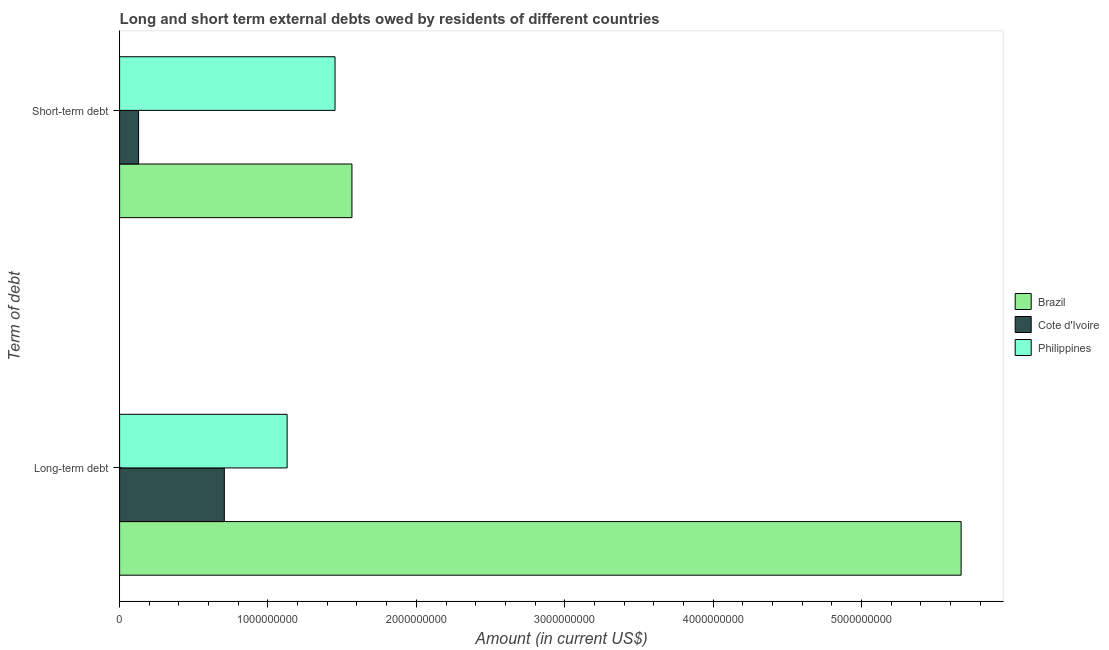How many groups of bars are there?
Provide a short and direct response. 2. Are the number of bars on each tick of the Y-axis equal?
Offer a terse response. Yes. What is the label of the 2nd group of bars from the top?
Provide a short and direct response. Long-term debt. What is the long-term debts owed by residents in Cote d'Ivoire?
Your answer should be compact. 7.06e+08. Across all countries, what is the maximum short-term debts owed by residents?
Provide a succinct answer. 1.57e+09. Across all countries, what is the minimum long-term debts owed by residents?
Ensure brevity in your answer.  7.06e+08. In which country was the long-term debts owed by residents maximum?
Give a very brief answer. Brazil. In which country was the short-term debts owed by residents minimum?
Provide a short and direct response. Cote d'Ivoire. What is the total short-term debts owed by residents in the graph?
Provide a short and direct response. 3.15e+09. What is the difference between the short-term debts owed by residents in Philippines and that in Brazil?
Keep it short and to the point. -1.14e+08. What is the difference between the long-term debts owed by residents in Brazil and the short-term debts owed by residents in Cote d'Ivoire?
Offer a terse response. 5.54e+09. What is the average long-term debts owed by residents per country?
Offer a very short reply. 2.50e+09. What is the difference between the long-term debts owed by residents and short-term debts owed by residents in Brazil?
Keep it short and to the point. 4.11e+09. In how many countries, is the long-term debts owed by residents greater than 3600000000 US$?
Offer a terse response. 1. What is the ratio of the short-term debts owed by residents in Philippines to that in Brazil?
Provide a succinct answer. 0.93. Is the short-term debts owed by residents in Brazil less than that in Philippines?
Make the answer very short. No. In how many countries, is the long-term debts owed by residents greater than the average long-term debts owed by residents taken over all countries?
Provide a succinct answer. 1. What does the 1st bar from the bottom in Long-term debt represents?
Offer a terse response. Brazil. How many bars are there?
Give a very brief answer. 6. What is the difference between two consecutive major ticks on the X-axis?
Keep it short and to the point. 1.00e+09. Are the values on the major ticks of X-axis written in scientific E-notation?
Offer a terse response. No. Does the graph contain any zero values?
Provide a succinct answer. No. Does the graph contain grids?
Make the answer very short. No. How are the legend labels stacked?
Make the answer very short. Vertical. What is the title of the graph?
Your response must be concise. Long and short term external debts owed by residents of different countries. What is the label or title of the Y-axis?
Provide a succinct answer. Term of debt. What is the Amount (in current US$) of Brazil in Long-term debt?
Your response must be concise. 5.67e+09. What is the Amount (in current US$) of Cote d'Ivoire in Long-term debt?
Provide a short and direct response. 7.06e+08. What is the Amount (in current US$) in Philippines in Long-term debt?
Offer a very short reply. 1.13e+09. What is the Amount (in current US$) of Brazil in Short-term debt?
Give a very brief answer. 1.57e+09. What is the Amount (in current US$) of Cote d'Ivoire in Short-term debt?
Offer a very short reply. 1.28e+08. What is the Amount (in current US$) in Philippines in Short-term debt?
Offer a terse response. 1.45e+09. Across all Term of debt, what is the maximum Amount (in current US$) in Brazil?
Make the answer very short. 5.67e+09. Across all Term of debt, what is the maximum Amount (in current US$) in Cote d'Ivoire?
Offer a terse response. 7.06e+08. Across all Term of debt, what is the maximum Amount (in current US$) in Philippines?
Ensure brevity in your answer.  1.45e+09. Across all Term of debt, what is the minimum Amount (in current US$) in Brazil?
Ensure brevity in your answer.  1.57e+09. Across all Term of debt, what is the minimum Amount (in current US$) of Cote d'Ivoire?
Offer a terse response. 1.28e+08. Across all Term of debt, what is the minimum Amount (in current US$) in Philippines?
Offer a terse response. 1.13e+09. What is the total Amount (in current US$) of Brazil in the graph?
Your response must be concise. 7.24e+09. What is the total Amount (in current US$) in Cote d'Ivoire in the graph?
Your response must be concise. 8.34e+08. What is the total Amount (in current US$) in Philippines in the graph?
Your answer should be compact. 2.58e+09. What is the difference between the Amount (in current US$) in Brazil in Long-term debt and that in Short-term debt?
Your answer should be compact. 4.11e+09. What is the difference between the Amount (in current US$) of Cote d'Ivoire in Long-term debt and that in Short-term debt?
Give a very brief answer. 5.78e+08. What is the difference between the Amount (in current US$) of Philippines in Long-term debt and that in Short-term debt?
Your response must be concise. -3.23e+08. What is the difference between the Amount (in current US$) of Brazil in Long-term debt and the Amount (in current US$) of Cote d'Ivoire in Short-term debt?
Keep it short and to the point. 5.54e+09. What is the difference between the Amount (in current US$) of Brazil in Long-term debt and the Amount (in current US$) of Philippines in Short-term debt?
Make the answer very short. 4.22e+09. What is the difference between the Amount (in current US$) of Cote d'Ivoire in Long-term debt and the Amount (in current US$) of Philippines in Short-term debt?
Give a very brief answer. -7.46e+08. What is the average Amount (in current US$) of Brazil per Term of debt?
Your answer should be compact. 3.62e+09. What is the average Amount (in current US$) in Cote d'Ivoire per Term of debt?
Your response must be concise. 4.17e+08. What is the average Amount (in current US$) in Philippines per Term of debt?
Make the answer very short. 1.29e+09. What is the difference between the Amount (in current US$) in Brazil and Amount (in current US$) in Cote d'Ivoire in Long-term debt?
Make the answer very short. 4.97e+09. What is the difference between the Amount (in current US$) of Brazil and Amount (in current US$) of Philippines in Long-term debt?
Offer a very short reply. 4.54e+09. What is the difference between the Amount (in current US$) in Cote d'Ivoire and Amount (in current US$) in Philippines in Long-term debt?
Offer a terse response. -4.23e+08. What is the difference between the Amount (in current US$) of Brazil and Amount (in current US$) of Cote d'Ivoire in Short-term debt?
Your answer should be compact. 1.44e+09. What is the difference between the Amount (in current US$) of Brazil and Amount (in current US$) of Philippines in Short-term debt?
Offer a terse response. 1.14e+08. What is the difference between the Amount (in current US$) in Cote d'Ivoire and Amount (in current US$) in Philippines in Short-term debt?
Give a very brief answer. -1.32e+09. What is the ratio of the Amount (in current US$) of Brazil in Long-term debt to that in Short-term debt?
Offer a very short reply. 3.62. What is the ratio of the Amount (in current US$) in Cote d'Ivoire in Long-term debt to that in Short-term debt?
Your answer should be very brief. 5.51. What is the ratio of the Amount (in current US$) in Philippines in Long-term debt to that in Short-term debt?
Make the answer very short. 0.78. What is the difference between the highest and the second highest Amount (in current US$) in Brazil?
Ensure brevity in your answer.  4.11e+09. What is the difference between the highest and the second highest Amount (in current US$) in Cote d'Ivoire?
Keep it short and to the point. 5.78e+08. What is the difference between the highest and the second highest Amount (in current US$) of Philippines?
Provide a short and direct response. 3.23e+08. What is the difference between the highest and the lowest Amount (in current US$) of Brazil?
Your response must be concise. 4.11e+09. What is the difference between the highest and the lowest Amount (in current US$) in Cote d'Ivoire?
Your answer should be very brief. 5.78e+08. What is the difference between the highest and the lowest Amount (in current US$) in Philippines?
Your answer should be compact. 3.23e+08. 